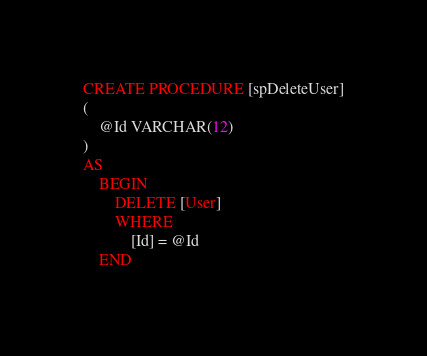Convert code to text. <code><loc_0><loc_0><loc_500><loc_500><_SQL_>CREATE PROCEDURE [spDeleteUser]
(
	@Id VARCHAR(12)
)
AS
	BEGIN
		DELETE [User]
		WHERE
			[Id] = @Id
	END
</code> 